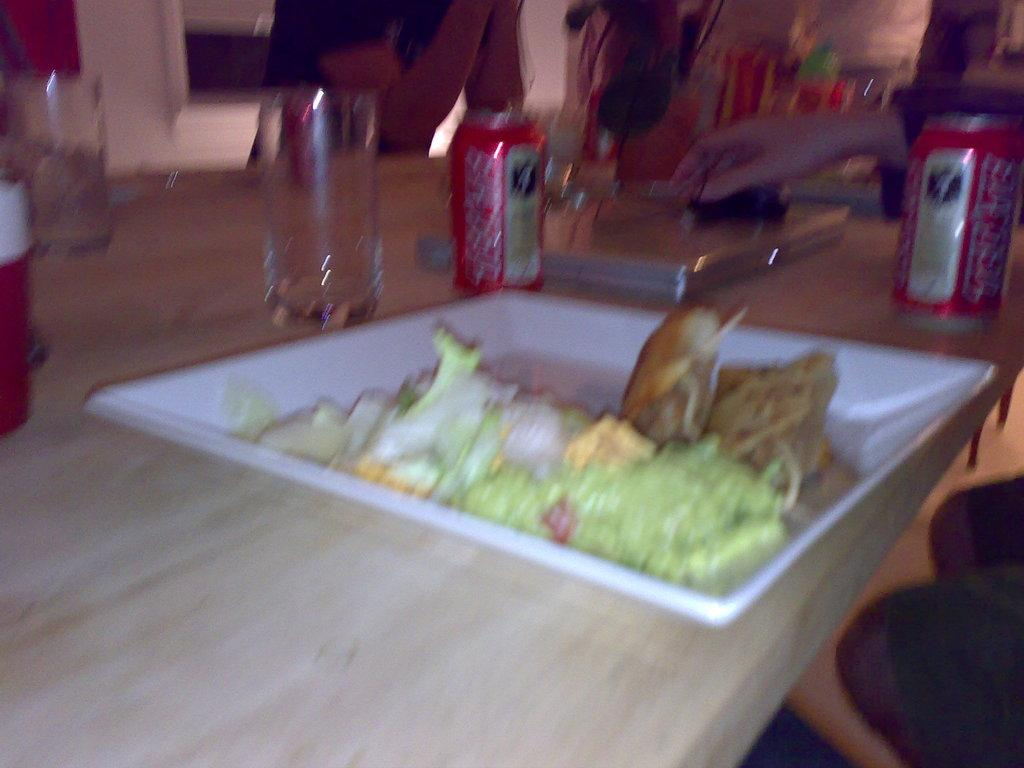What type of objects can be seen on the table in the image? There are glasses, beverage cans, and food on a plate in the image. What is the setting where the table is located? The image is taken in a hall. What might be used for drinking in the image? The glasses in the image might be used for drinking. What is placed on the plate in the image? There is food on a plate in the image. What type of feeling can be seen on the icicle in the image? There is no icicle present in the image, so it is not possible to determine any feelings on it. 